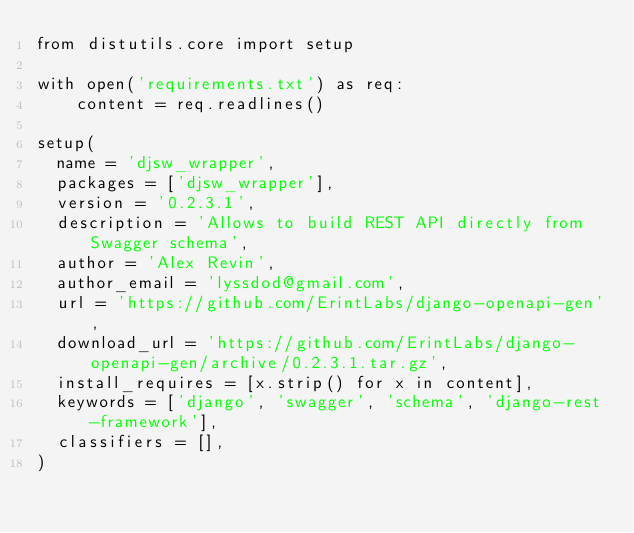Convert code to text. <code><loc_0><loc_0><loc_500><loc_500><_Python_>from distutils.core import setup

with open('requirements.txt') as req:
    content = req.readlines()

setup(
  name = 'djsw_wrapper',
  packages = ['djsw_wrapper'],
  version = '0.2.3.1',
  description = 'Allows to build REST API directly from Swagger schema',
  author = 'Alex Revin',
  author_email = 'lyssdod@gmail.com',
  url = 'https://github.com/ErintLabs/django-openapi-gen',
  download_url = 'https://github.com/ErintLabs/django-openapi-gen/archive/0.2.3.1.tar.gz',
  install_requires = [x.strip() for x in content],
  keywords = ['django', 'swagger', 'schema', 'django-rest-framework'],
  classifiers = [],
)
</code> 